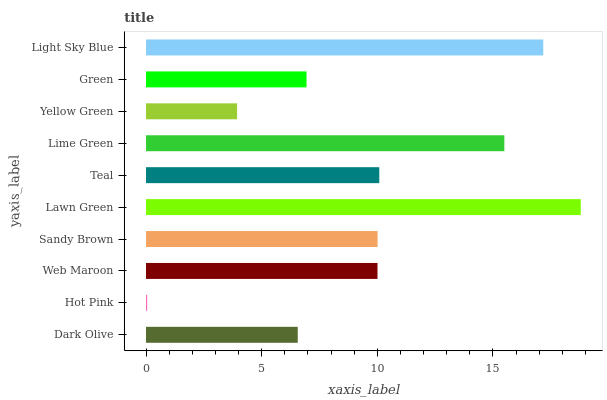Is Hot Pink the minimum?
Answer yes or no. Yes. Is Lawn Green the maximum?
Answer yes or no. Yes. Is Web Maroon the minimum?
Answer yes or no. No. Is Web Maroon the maximum?
Answer yes or no. No. Is Web Maroon greater than Hot Pink?
Answer yes or no. Yes. Is Hot Pink less than Web Maroon?
Answer yes or no. Yes. Is Hot Pink greater than Web Maroon?
Answer yes or no. No. Is Web Maroon less than Hot Pink?
Answer yes or no. No. Is Sandy Brown the high median?
Answer yes or no. Yes. Is Web Maroon the low median?
Answer yes or no. Yes. Is Yellow Green the high median?
Answer yes or no. No. Is Teal the low median?
Answer yes or no. No. 